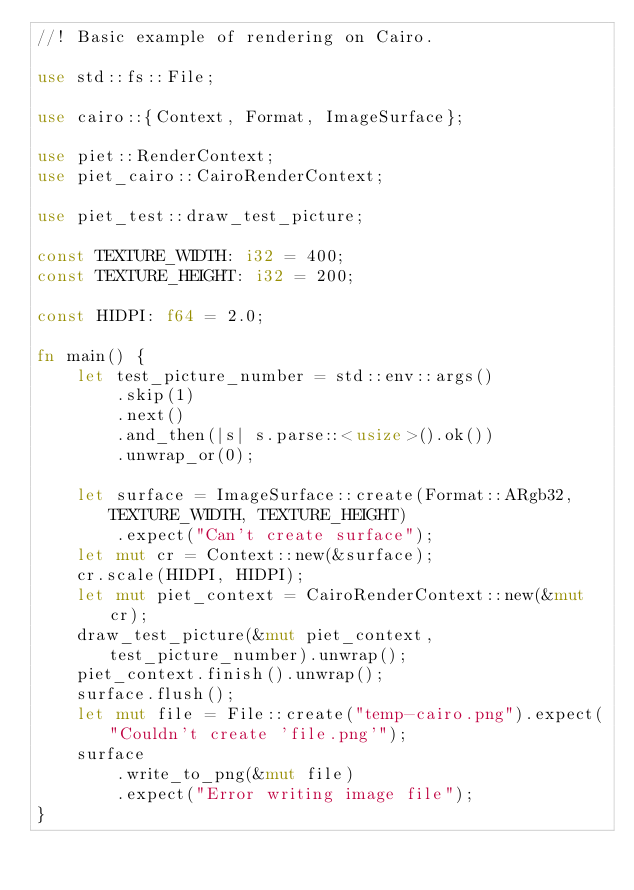<code> <loc_0><loc_0><loc_500><loc_500><_Rust_>//! Basic example of rendering on Cairo.

use std::fs::File;

use cairo::{Context, Format, ImageSurface};

use piet::RenderContext;
use piet_cairo::CairoRenderContext;

use piet_test::draw_test_picture;

const TEXTURE_WIDTH: i32 = 400;
const TEXTURE_HEIGHT: i32 = 200;

const HIDPI: f64 = 2.0;

fn main() {
    let test_picture_number = std::env::args()
        .skip(1)
        .next()
        .and_then(|s| s.parse::<usize>().ok())
        .unwrap_or(0);

    let surface = ImageSurface::create(Format::ARgb32, TEXTURE_WIDTH, TEXTURE_HEIGHT)
        .expect("Can't create surface");
    let mut cr = Context::new(&surface);
    cr.scale(HIDPI, HIDPI);
    let mut piet_context = CairoRenderContext::new(&mut cr);
    draw_test_picture(&mut piet_context, test_picture_number).unwrap();
    piet_context.finish().unwrap();
    surface.flush();
    let mut file = File::create("temp-cairo.png").expect("Couldn't create 'file.png'");
    surface
        .write_to_png(&mut file)
        .expect("Error writing image file");
}
</code> 